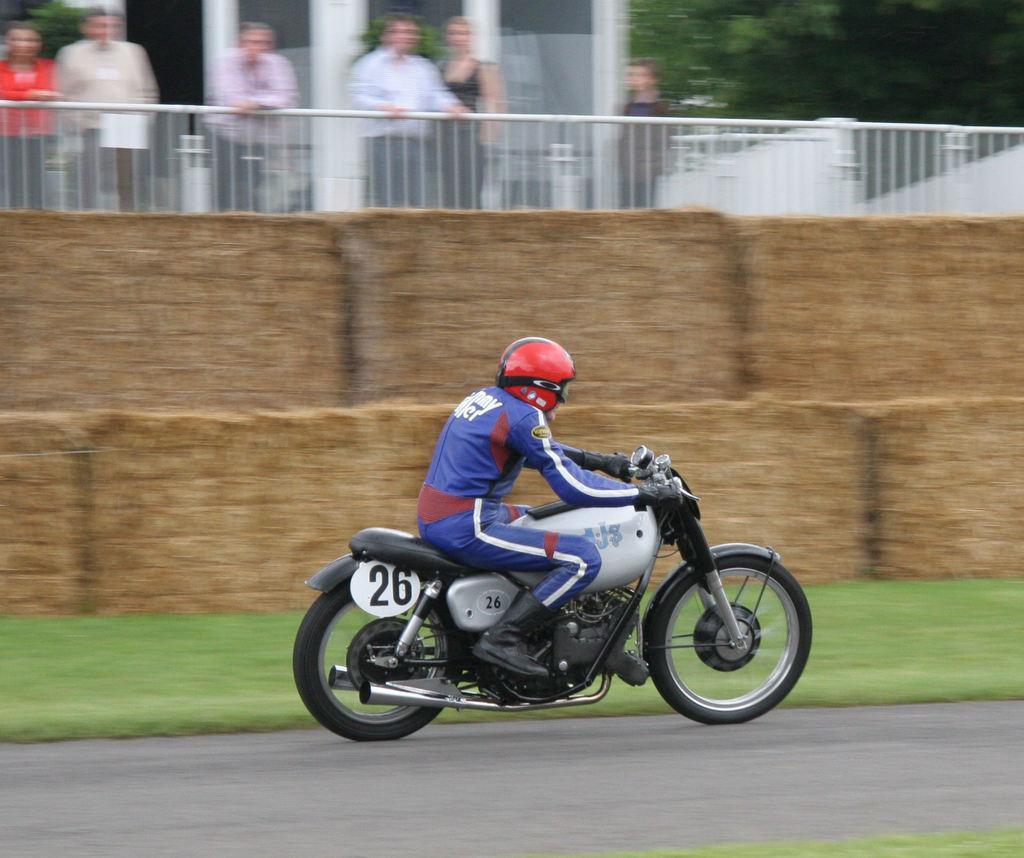In one or two sentences, can you explain what this image depicts? This picture is a person riding a motorcycle and his wearing a red color helmet 